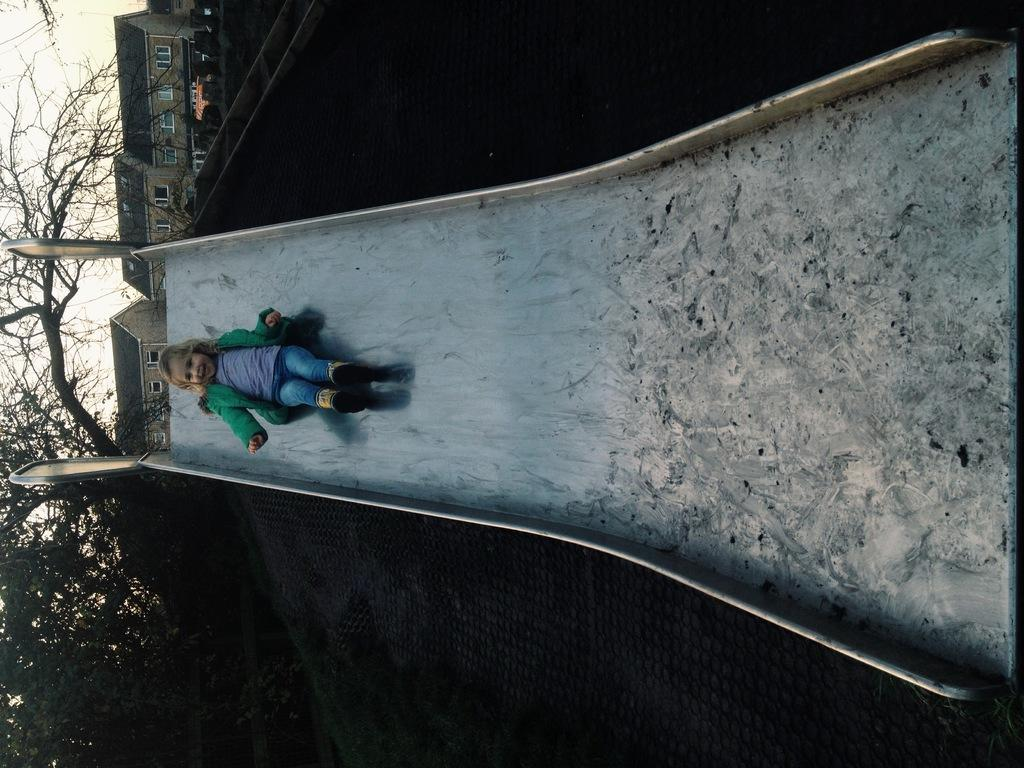Who is the main subject in the image? There is a girl in the image. What is the girl doing in the image? The girl is on a slide. What can be seen in the background of the image? There are houses, trees, and the sky visible in the background of the image. What type of friction can be observed between the girl and the slide in the image? There is no specific type of friction mentioned or observable in the image; it simply shows a girl on a slide. 